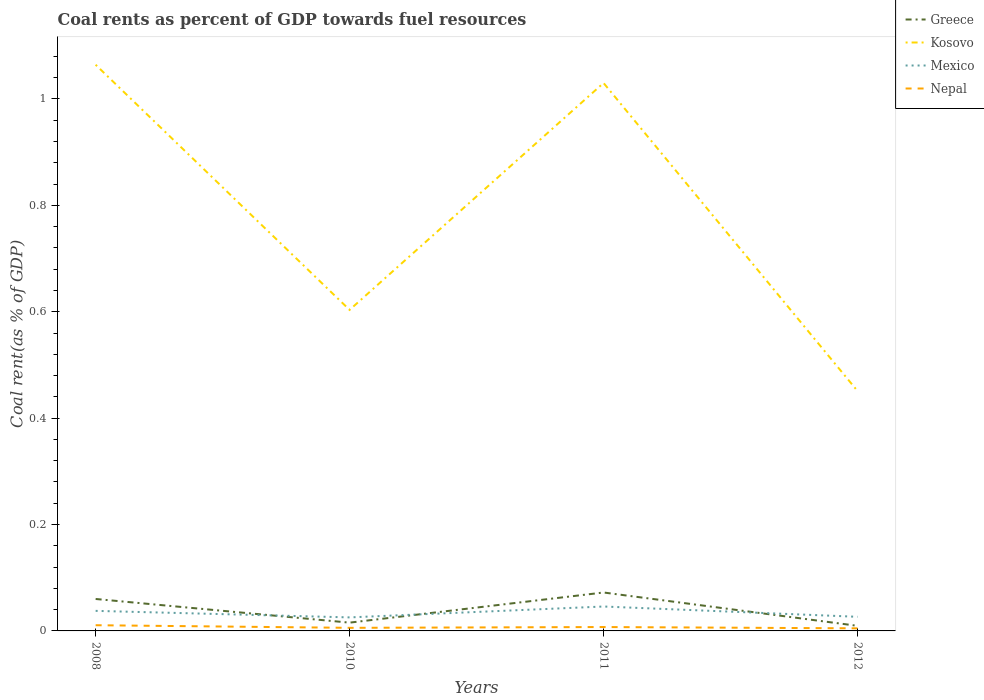How many different coloured lines are there?
Offer a terse response. 4. Does the line corresponding to Nepal intersect with the line corresponding to Kosovo?
Provide a succinct answer. No. Is the number of lines equal to the number of legend labels?
Provide a short and direct response. Yes. Across all years, what is the maximum coal rent in Mexico?
Keep it short and to the point. 0.03. In which year was the coal rent in Kosovo maximum?
Offer a very short reply. 2012. What is the total coal rent in Kosovo in the graph?
Your answer should be very brief. 0.61. What is the difference between the highest and the second highest coal rent in Greece?
Your answer should be very brief. 0.06. Is the coal rent in Kosovo strictly greater than the coal rent in Mexico over the years?
Your response must be concise. No. What is the difference between two consecutive major ticks on the Y-axis?
Offer a very short reply. 0.2. Are the values on the major ticks of Y-axis written in scientific E-notation?
Ensure brevity in your answer.  No. Does the graph contain any zero values?
Your answer should be very brief. No. Does the graph contain grids?
Offer a very short reply. No. How many legend labels are there?
Keep it short and to the point. 4. What is the title of the graph?
Give a very brief answer. Coal rents as percent of GDP towards fuel resources. Does "Madagascar" appear as one of the legend labels in the graph?
Your answer should be compact. No. What is the label or title of the X-axis?
Give a very brief answer. Years. What is the label or title of the Y-axis?
Provide a short and direct response. Coal rent(as % of GDP). What is the Coal rent(as % of GDP) in Greece in 2008?
Provide a succinct answer. 0.06. What is the Coal rent(as % of GDP) in Kosovo in 2008?
Offer a terse response. 1.06. What is the Coal rent(as % of GDP) in Mexico in 2008?
Your answer should be compact. 0.04. What is the Coal rent(as % of GDP) of Nepal in 2008?
Offer a terse response. 0.01. What is the Coal rent(as % of GDP) of Greece in 2010?
Keep it short and to the point. 0.02. What is the Coal rent(as % of GDP) of Kosovo in 2010?
Your response must be concise. 0.6. What is the Coal rent(as % of GDP) in Mexico in 2010?
Keep it short and to the point. 0.03. What is the Coal rent(as % of GDP) in Nepal in 2010?
Your response must be concise. 0.01. What is the Coal rent(as % of GDP) in Greece in 2011?
Provide a succinct answer. 0.07. What is the Coal rent(as % of GDP) of Kosovo in 2011?
Offer a very short reply. 1.03. What is the Coal rent(as % of GDP) of Mexico in 2011?
Offer a very short reply. 0.05. What is the Coal rent(as % of GDP) of Nepal in 2011?
Offer a terse response. 0.01. What is the Coal rent(as % of GDP) of Greece in 2012?
Offer a very short reply. 0.01. What is the Coal rent(as % of GDP) in Kosovo in 2012?
Your answer should be compact. 0.45. What is the Coal rent(as % of GDP) of Mexico in 2012?
Ensure brevity in your answer.  0.03. What is the Coal rent(as % of GDP) in Nepal in 2012?
Keep it short and to the point. 0. Across all years, what is the maximum Coal rent(as % of GDP) of Greece?
Keep it short and to the point. 0.07. Across all years, what is the maximum Coal rent(as % of GDP) in Kosovo?
Offer a terse response. 1.06. Across all years, what is the maximum Coal rent(as % of GDP) of Mexico?
Your answer should be very brief. 0.05. Across all years, what is the maximum Coal rent(as % of GDP) in Nepal?
Make the answer very short. 0.01. Across all years, what is the minimum Coal rent(as % of GDP) in Greece?
Offer a very short reply. 0.01. Across all years, what is the minimum Coal rent(as % of GDP) in Kosovo?
Your response must be concise. 0.45. Across all years, what is the minimum Coal rent(as % of GDP) in Mexico?
Make the answer very short. 0.03. Across all years, what is the minimum Coal rent(as % of GDP) of Nepal?
Provide a succinct answer. 0. What is the total Coal rent(as % of GDP) of Greece in the graph?
Keep it short and to the point. 0.16. What is the total Coal rent(as % of GDP) in Kosovo in the graph?
Your response must be concise. 3.15. What is the total Coal rent(as % of GDP) in Mexico in the graph?
Make the answer very short. 0.14. What is the total Coal rent(as % of GDP) in Nepal in the graph?
Give a very brief answer. 0.03. What is the difference between the Coal rent(as % of GDP) of Greece in 2008 and that in 2010?
Provide a short and direct response. 0.04. What is the difference between the Coal rent(as % of GDP) of Kosovo in 2008 and that in 2010?
Offer a very short reply. 0.46. What is the difference between the Coal rent(as % of GDP) in Mexico in 2008 and that in 2010?
Your answer should be compact. 0.01. What is the difference between the Coal rent(as % of GDP) in Nepal in 2008 and that in 2010?
Your response must be concise. 0. What is the difference between the Coal rent(as % of GDP) in Greece in 2008 and that in 2011?
Provide a succinct answer. -0.01. What is the difference between the Coal rent(as % of GDP) of Kosovo in 2008 and that in 2011?
Keep it short and to the point. 0.03. What is the difference between the Coal rent(as % of GDP) in Mexico in 2008 and that in 2011?
Offer a very short reply. -0.01. What is the difference between the Coal rent(as % of GDP) of Nepal in 2008 and that in 2011?
Your response must be concise. 0. What is the difference between the Coal rent(as % of GDP) of Greece in 2008 and that in 2012?
Ensure brevity in your answer.  0.05. What is the difference between the Coal rent(as % of GDP) of Kosovo in 2008 and that in 2012?
Provide a succinct answer. 0.61. What is the difference between the Coal rent(as % of GDP) in Mexico in 2008 and that in 2012?
Your answer should be very brief. 0.01. What is the difference between the Coal rent(as % of GDP) in Nepal in 2008 and that in 2012?
Offer a very short reply. 0.01. What is the difference between the Coal rent(as % of GDP) of Greece in 2010 and that in 2011?
Offer a terse response. -0.06. What is the difference between the Coal rent(as % of GDP) of Kosovo in 2010 and that in 2011?
Ensure brevity in your answer.  -0.43. What is the difference between the Coal rent(as % of GDP) in Mexico in 2010 and that in 2011?
Give a very brief answer. -0.02. What is the difference between the Coal rent(as % of GDP) of Nepal in 2010 and that in 2011?
Provide a succinct answer. -0. What is the difference between the Coal rent(as % of GDP) of Greece in 2010 and that in 2012?
Ensure brevity in your answer.  0.01. What is the difference between the Coal rent(as % of GDP) in Kosovo in 2010 and that in 2012?
Your answer should be very brief. 0.15. What is the difference between the Coal rent(as % of GDP) of Mexico in 2010 and that in 2012?
Give a very brief answer. -0. What is the difference between the Coal rent(as % of GDP) of Nepal in 2010 and that in 2012?
Your answer should be very brief. 0. What is the difference between the Coal rent(as % of GDP) of Greece in 2011 and that in 2012?
Keep it short and to the point. 0.06. What is the difference between the Coal rent(as % of GDP) in Kosovo in 2011 and that in 2012?
Your response must be concise. 0.58. What is the difference between the Coal rent(as % of GDP) in Mexico in 2011 and that in 2012?
Provide a short and direct response. 0.02. What is the difference between the Coal rent(as % of GDP) in Nepal in 2011 and that in 2012?
Ensure brevity in your answer.  0. What is the difference between the Coal rent(as % of GDP) of Greece in 2008 and the Coal rent(as % of GDP) of Kosovo in 2010?
Offer a terse response. -0.54. What is the difference between the Coal rent(as % of GDP) in Greece in 2008 and the Coal rent(as % of GDP) in Mexico in 2010?
Your response must be concise. 0.03. What is the difference between the Coal rent(as % of GDP) of Greece in 2008 and the Coal rent(as % of GDP) of Nepal in 2010?
Offer a very short reply. 0.05. What is the difference between the Coal rent(as % of GDP) of Kosovo in 2008 and the Coal rent(as % of GDP) of Mexico in 2010?
Provide a short and direct response. 1.04. What is the difference between the Coal rent(as % of GDP) of Kosovo in 2008 and the Coal rent(as % of GDP) of Nepal in 2010?
Offer a terse response. 1.06. What is the difference between the Coal rent(as % of GDP) in Mexico in 2008 and the Coal rent(as % of GDP) in Nepal in 2010?
Your answer should be compact. 0.03. What is the difference between the Coal rent(as % of GDP) of Greece in 2008 and the Coal rent(as % of GDP) of Kosovo in 2011?
Your answer should be very brief. -0.97. What is the difference between the Coal rent(as % of GDP) in Greece in 2008 and the Coal rent(as % of GDP) in Mexico in 2011?
Ensure brevity in your answer.  0.01. What is the difference between the Coal rent(as % of GDP) in Greece in 2008 and the Coal rent(as % of GDP) in Nepal in 2011?
Your answer should be very brief. 0.05. What is the difference between the Coal rent(as % of GDP) of Kosovo in 2008 and the Coal rent(as % of GDP) of Mexico in 2011?
Your response must be concise. 1.02. What is the difference between the Coal rent(as % of GDP) in Kosovo in 2008 and the Coal rent(as % of GDP) in Nepal in 2011?
Give a very brief answer. 1.06. What is the difference between the Coal rent(as % of GDP) in Mexico in 2008 and the Coal rent(as % of GDP) in Nepal in 2011?
Ensure brevity in your answer.  0.03. What is the difference between the Coal rent(as % of GDP) in Greece in 2008 and the Coal rent(as % of GDP) in Kosovo in 2012?
Your answer should be compact. -0.39. What is the difference between the Coal rent(as % of GDP) in Greece in 2008 and the Coal rent(as % of GDP) in Mexico in 2012?
Offer a very short reply. 0.03. What is the difference between the Coal rent(as % of GDP) of Greece in 2008 and the Coal rent(as % of GDP) of Nepal in 2012?
Ensure brevity in your answer.  0.06. What is the difference between the Coal rent(as % of GDP) of Kosovo in 2008 and the Coal rent(as % of GDP) of Mexico in 2012?
Give a very brief answer. 1.04. What is the difference between the Coal rent(as % of GDP) in Kosovo in 2008 and the Coal rent(as % of GDP) in Nepal in 2012?
Keep it short and to the point. 1.06. What is the difference between the Coal rent(as % of GDP) of Mexico in 2008 and the Coal rent(as % of GDP) of Nepal in 2012?
Offer a terse response. 0.03. What is the difference between the Coal rent(as % of GDP) of Greece in 2010 and the Coal rent(as % of GDP) of Kosovo in 2011?
Offer a terse response. -1.01. What is the difference between the Coal rent(as % of GDP) of Greece in 2010 and the Coal rent(as % of GDP) of Mexico in 2011?
Give a very brief answer. -0.03. What is the difference between the Coal rent(as % of GDP) of Greece in 2010 and the Coal rent(as % of GDP) of Nepal in 2011?
Offer a terse response. 0.01. What is the difference between the Coal rent(as % of GDP) in Kosovo in 2010 and the Coal rent(as % of GDP) in Mexico in 2011?
Make the answer very short. 0.56. What is the difference between the Coal rent(as % of GDP) in Kosovo in 2010 and the Coal rent(as % of GDP) in Nepal in 2011?
Your answer should be very brief. 0.6. What is the difference between the Coal rent(as % of GDP) in Mexico in 2010 and the Coal rent(as % of GDP) in Nepal in 2011?
Your response must be concise. 0.02. What is the difference between the Coal rent(as % of GDP) in Greece in 2010 and the Coal rent(as % of GDP) in Kosovo in 2012?
Offer a terse response. -0.44. What is the difference between the Coal rent(as % of GDP) of Greece in 2010 and the Coal rent(as % of GDP) of Mexico in 2012?
Offer a terse response. -0.01. What is the difference between the Coal rent(as % of GDP) in Greece in 2010 and the Coal rent(as % of GDP) in Nepal in 2012?
Your response must be concise. 0.01. What is the difference between the Coal rent(as % of GDP) in Kosovo in 2010 and the Coal rent(as % of GDP) in Mexico in 2012?
Offer a very short reply. 0.58. What is the difference between the Coal rent(as % of GDP) in Kosovo in 2010 and the Coal rent(as % of GDP) in Nepal in 2012?
Make the answer very short. 0.6. What is the difference between the Coal rent(as % of GDP) in Mexico in 2010 and the Coal rent(as % of GDP) in Nepal in 2012?
Provide a succinct answer. 0.02. What is the difference between the Coal rent(as % of GDP) of Greece in 2011 and the Coal rent(as % of GDP) of Kosovo in 2012?
Provide a succinct answer. -0.38. What is the difference between the Coal rent(as % of GDP) in Greece in 2011 and the Coal rent(as % of GDP) in Mexico in 2012?
Give a very brief answer. 0.05. What is the difference between the Coal rent(as % of GDP) of Greece in 2011 and the Coal rent(as % of GDP) of Nepal in 2012?
Provide a short and direct response. 0.07. What is the difference between the Coal rent(as % of GDP) of Kosovo in 2011 and the Coal rent(as % of GDP) of Nepal in 2012?
Offer a terse response. 1.03. What is the difference between the Coal rent(as % of GDP) of Mexico in 2011 and the Coal rent(as % of GDP) of Nepal in 2012?
Your answer should be very brief. 0.04. What is the average Coal rent(as % of GDP) of Greece per year?
Provide a succinct answer. 0.04. What is the average Coal rent(as % of GDP) of Kosovo per year?
Offer a terse response. 0.79. What is the average Coal rent(as % of GDP) of Mexico per year?
Ensure brevity in your answer.  0.03. What is the average Coal rent(as % of GDP) in Nepal per year?
Provide a short and direct response. 0.01. In the year 2008, what is the difference between the Coal rent(as % of GDP) in Greece and Coal rent(as % of GDP) in Kosovo?
Your answer should be very brief. -1. In the year 2008, what is the difference between the Coal rent(as % of GDP) in Greece and Coal rent(as % of GDP) in Mexico?
Keep it short and to the point. 0.02. In the year 2008, what is the difference between the Coal rent(as % of GDP) of Greece and Coal rent(as % of GDP) of Nepal?
Your answer should be compact. 0.05. In the year 2008, what is the difference between the Coal rent(as % of GDP) of Kosovo and Coal rent(as % of GDP) of Mexico?
Give a very brief answer. 1.03. In the year 2008, what is the difference between the Coal rent(as % of GDP) in Kosovo and Coal rent(as % of GDP) in Nepal?
Your answer should be compact. 1.05. In the year 2008, what is the difference between the Coal rent(as % of GDP) in Mexico and Coal rent(as % of GDP) in Nepal?
Provide a succinct answer. 0.03. In the year 2010, what is the difference between the Coal rent(as % of GDP) of Greece and Coal rent(as % of GDP) of Kosovo?
Offer a very short reply. -0.59. In the year 2010, what is the difference between the Coal rent(as % of GDP) of Greece and Coal rent(as % of GDP) of Mexico?
Provide a short and direct response. -0.01. In the year 2010, what is the difference between the Coal rent(as % of GDP) of Greece and Coal rent(as % of GDP) of Nepal?
Give a very brief answer. 0.01. In the year 2010, what is the difference between the Coal rent(as % of GDP) of Kosovo and Coal rent(as % of GDP) of Mexico?
Your response must be concise. 0.58. In the year 2010, what is the difference between the Coal rent(as % of GDP) of Kosovo and Coal rent(as % of GDP) of Nepal?
Give a very brief answer. 0.6. In the year 2010, what is the difference between the Coal rent(as % of GDP) in Mexico and Coal rent(as % of GDP) in Nepal?
Your response must be concise. 0.02. In the year 2011, what is the difference between the Coal rent(as % of GDP) of Greece and Coal rent(as % of GDP) of Kosovo?
Keep it short and to the point. -0.96. In the year 2011, what is the difference between the Coal rent(as % of GDP) in Greece and Coal rent(as % of GDP) in Mexico?
Your answer should be compact. 0.03. In the year 2011, what is the difference between the Coal rent(as % of GDP) in Greece and Coal rent(as % of GDP) in Nepal?
Offer a very short reply. 0.06. In the year 2011, what is the difference between the Coal rent(as % of GDP) of Kosovo and Coal rent(as % of GDP) of Mexico?
Your response must be concise. 0.98. In the year 2011, what is the difference between the Coal rent(as % of GDP) of Kosovo and Coal rent(as % of GDP) of Nepal?
Ensure brevity in your answer.  1.02. In the year 2011, what is the difference between the Coal rent(as % of GDP) of Mexico and Coal rent(as % of GDP) of Nepal?
Give a very brief answer. 0.04. In the year 2012, what is the difference between the Coal rent(as % of GDP) in Greece and Coal rent(as % of GDP) in Kosovo?
Make the answer very short. -0.44. In the year 2012, what is the difference between the Coal rent(as % of GDP) of Greece and Coal rent(as % of GDP) of Mexico?
Your answer should be compact. -0.02. In the year 2012, what is the difference between the Coal rent(as % of GDP) in Greece and Coal rent(as % of GDP) in Nepal?
Your response must be concise. 0. In the year 2012, what is the difference between the Coal rent(as % of GDP) in Kosovo and Coal rent(as % of GDP) in Mexico?
Provide a short and direct response. 0.42. In the year 2012, what is the difference between the Coal rent(as % of GDP) in Kosovo and Coal rent(as % of GDP) in Nepal?
Provide a succinct answer. 0.45. In the year 2012, what is the difference between the Coal rent(as % of GDP) of Mexico and Coal rent(as % of GDP) of Nepal?
Make the answer very short. 0.02. What is the ratio of the Coal rent(as % of GDP) of Greece in 2008 to that in 2010?
Keep it short and to the point. 3.86. What is the ratio of the Coal rent(as % of GDP) in Kosovo in 2008 to that in 2010?
Your answer should be very brief. 1.76. What is the ratio of the Coal rent(as % of GDP) in Mexico in 2008 to that in 2010?
Keep it short and to the point. 1.48. What is the ratio of the Coal rent(as % of GDP) of Nepal in 2008 to that in 2010?
Offer a terse response. 1.85. What is the ratio of the Coal rent(as % of GDP) of Greece in 2008 to that in 2011?
Offer a very short reply. 0.83. What is the ratio of the Coal rent(as % of GDP) of Kosovo in 2008 to that in 2011?
Offer a terse response. 1.03. What is the ratio of the Coal rent(as % of GDP) in Mexico in 2008 to that in 2011?
Offer a very short reply. 0.82. What is the ratio of the Coal rent(as % of GDP) of Nepal in 2008 to that in 2011?
Keep it short and to the point. 1.47. What is the ratio of the Coal rent(as % of GDP) in Greece in 2008 to that in 2012?
Provide a short and direct response. 6.27. What is the ratio of the Coal rent(as % of GDP) of Kosovo in 2008 to that in 2012?
Your response must be concise. 2.36. What is the ratio of the Coal rent(as % of GDP) in Mexico in 2008 to that in 2012?
Offer a terse response. 1.42. What is the ratio of the Coal rent(as % of GDP) of Nepal in 2008 to that in 2012?
Your answer should be very brief. 2.2. What is the ratio of the Coal rent(as % of GDP) of Greece in 2010 to that in 2011?
Your response must be concise. 0.22. What is the ratio of the Coal rent(as % of GDP) of Kosovo in 2010 to that in 2011?
Make the answer very short. 0.59. What is the ratio of the Coal rent(as % of GDP) in Mexico in 2010 to that in 2011?
Your answer should be very brief. 0.55. What is the ratio of the Coal rent(as % of GDP) in Nepal in 2010 to that in 2011?
Your answer should be compact. 0.79. What is the ratio of the Coal rent(as % of GDP) in Greece in 2010 to that in 2012?
Provide a succinct answer. 1.63. What is the ratio of the Coal rent(as % of GDP) of Kosovo in 2010 to that in 2012?
Your answer should be very brief. 1.34. What is the ratio of the Coal rent(as % of GDP) in Mexico in 2010 to that in 2012?
Provide a succinct answer. 0.96. What is the ratio of the Coal rent(as % of GDP) of Nepal in 2010 to that in 2012?
Ensure brevity in your answer.  1.19. What is the ratio of the Coal rent(as % of GDP) in Greece in 2011 to that in 2012?
Your answer should be very brief. 7.54. What is the ratio of the Coal rent(as % of GDP) of Kosovo in 2011 to that in 2012?
Keep it short and to the point. 2.28. What is the ratio of the Coal rent(as % of GDP) in Mexico in 2011 to that in 2012?
Offer a very short reply. 1.73. What is the ratio of the Coal rent(as % of GDP) in Nepal in 2011 to that in 2012?
Offer a very short reply. 1.5. What is the difference between the highest and the second highest Coal rent(as % of GDP) in Greece?
Provide a short and direct response. 0.01. What is the difference between the highest and the second highest Coal rent(as % of GDP) of Kosovo?
Keep it short and to the point. 0.03. What is the difference between the highest and the second highest Coal rent(as % of GDP) in Mexico?
Provide a succinct answer. 0.01. What is the difference between the highest and the second highest Coal rent(as % of GDP) in Nepal?
Your response must be concise. 0. What is the difference between the highest and the lowest Coal rent(as % of GDP) in Greece?
Offer a very short reply. 0.06. What is the difference between the highest and the lowest Coal rent(as % of GDP) in Kosovo?
Keep it short and to the point. 0.61. What is the difference between the highest and the lowest Coal rent(as % of GDP) in Mexico?
Provide a succinct answer. 0.02. What is the difference between the highest and the lowest Coal rent(as % of GDP) in Nepal?
Offer a very short reply. 0.01. 